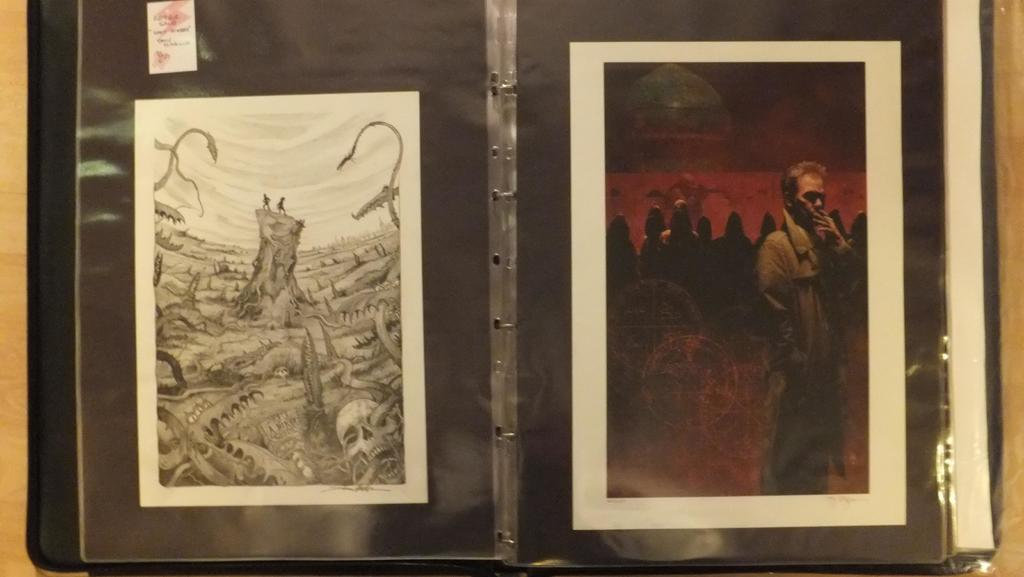What is on the table in the image? There is a file on the table in the image. What is inside the file? The file contains posters. How much dirt is visible on the posters in the image? There is no dirt visible on the posters in the image, as the facts provided do not mention any dirt. What type of prose can be read on the posters in the image? The facts provided do not mention any prose on the posters, so it cannot be determined from the image. 